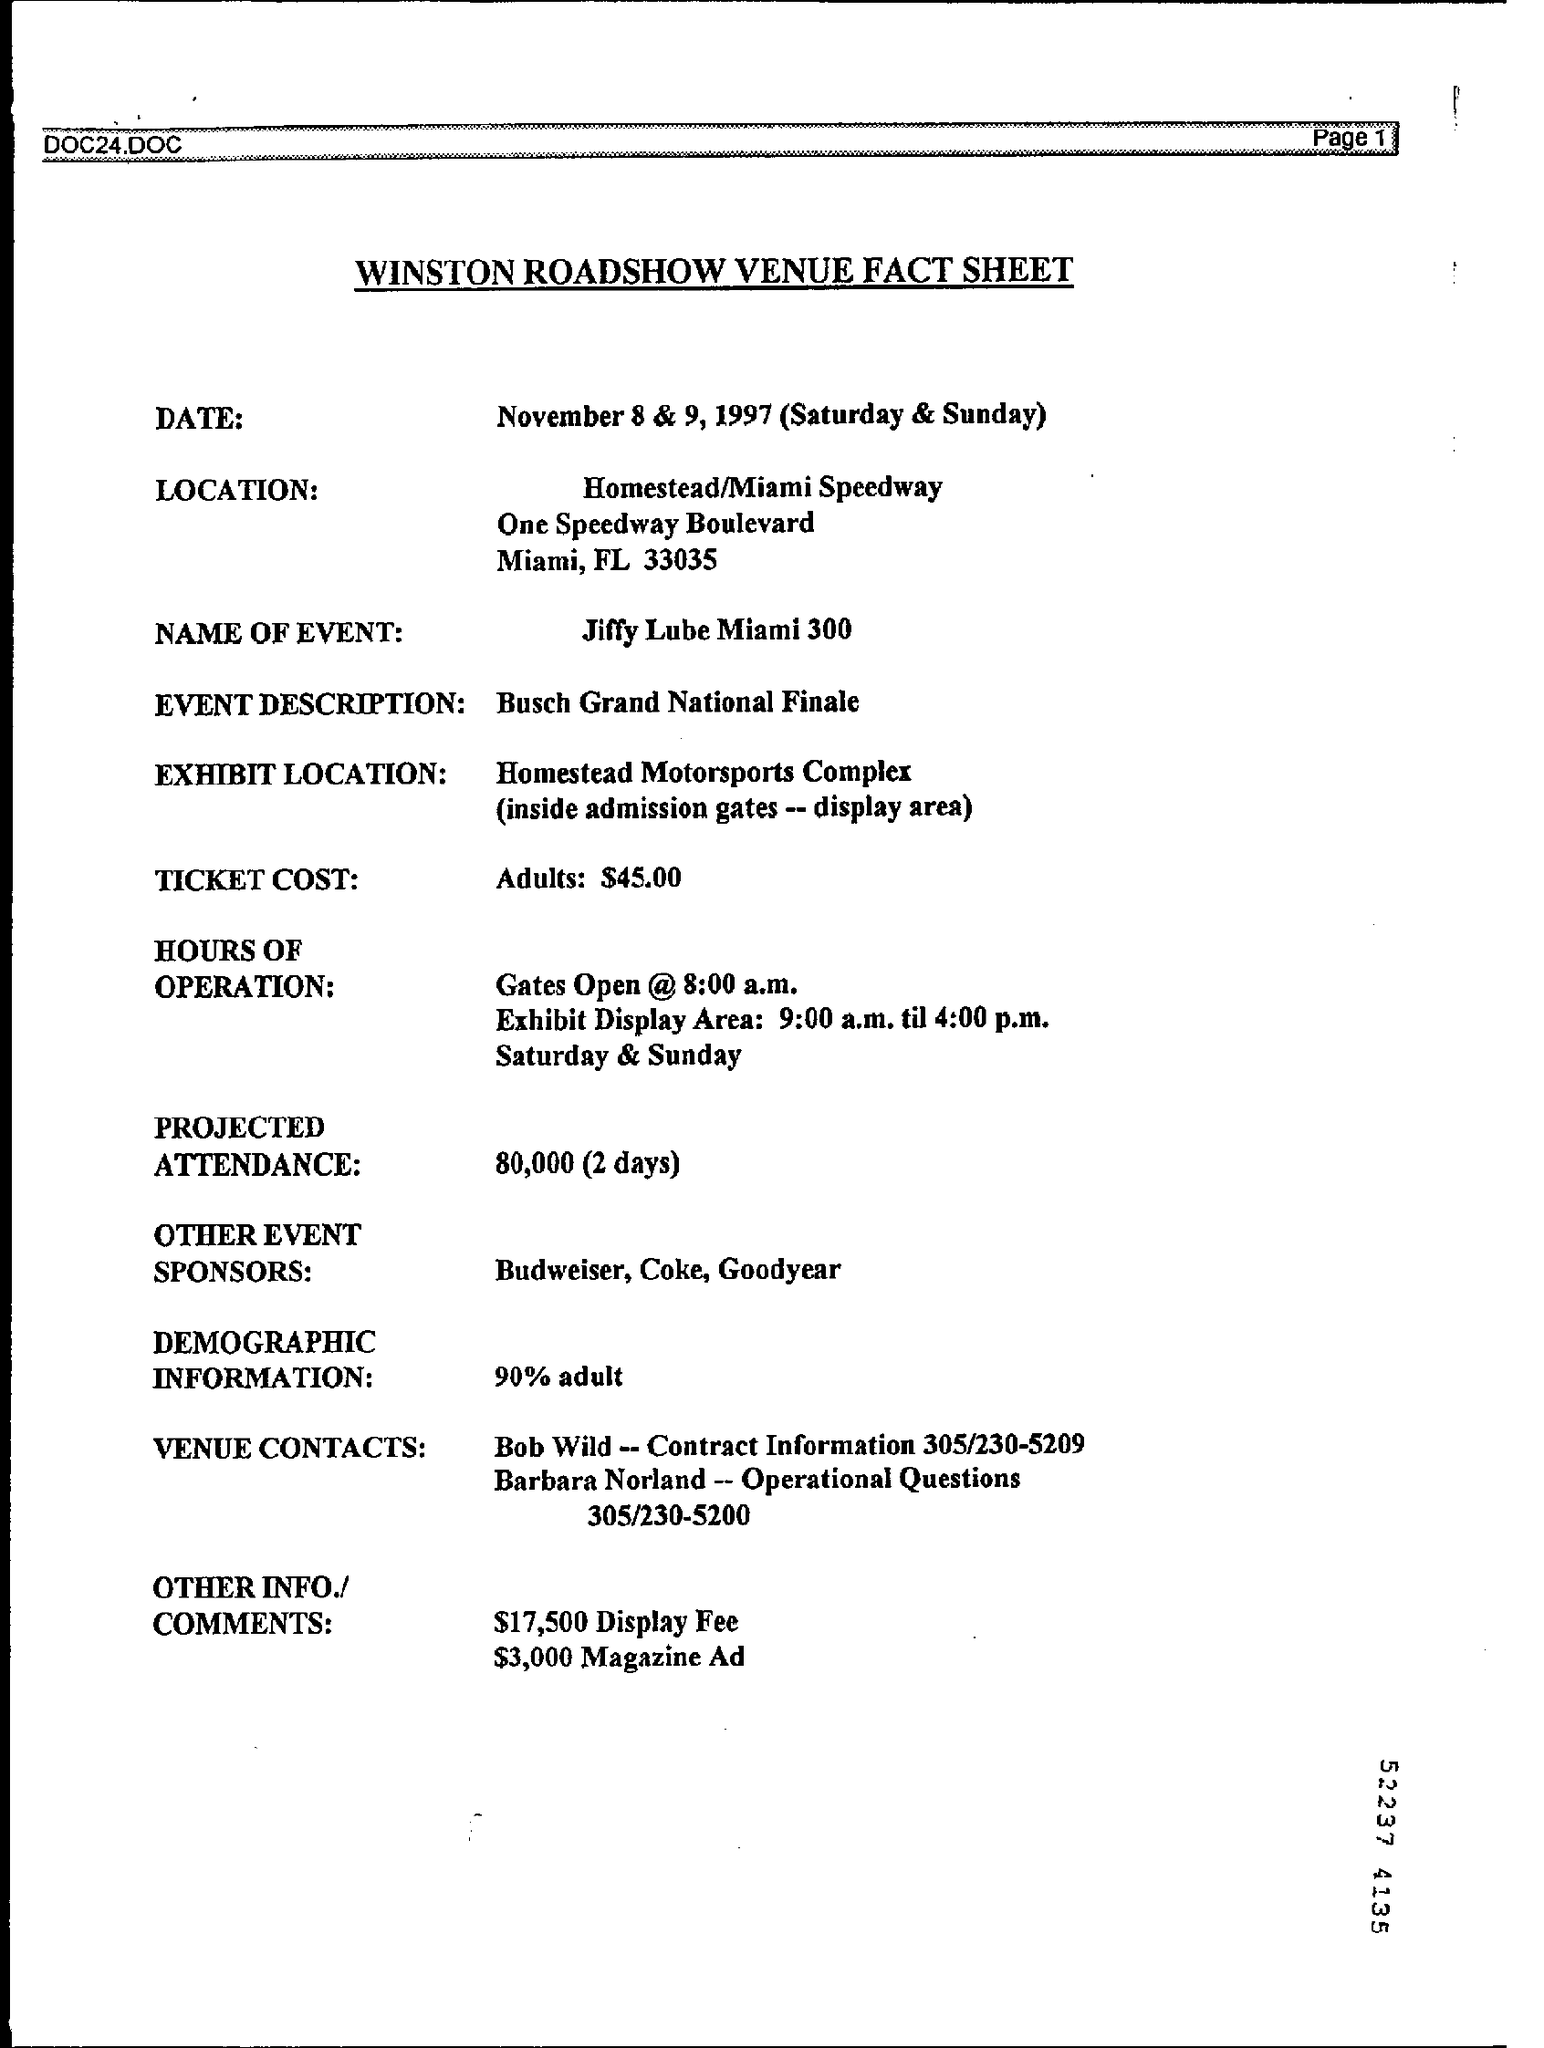What is the heading of this sheet
Provide a short and direct response. WINSTON ROADSHOW VENUE FACT SHEET. What is the name of event given in sheet
Ensure brevity in your answer.  Jiffy Lube Miami 300. What is the Ticket cost  for event
Keep it short and to the point. Adults: $45.00. 